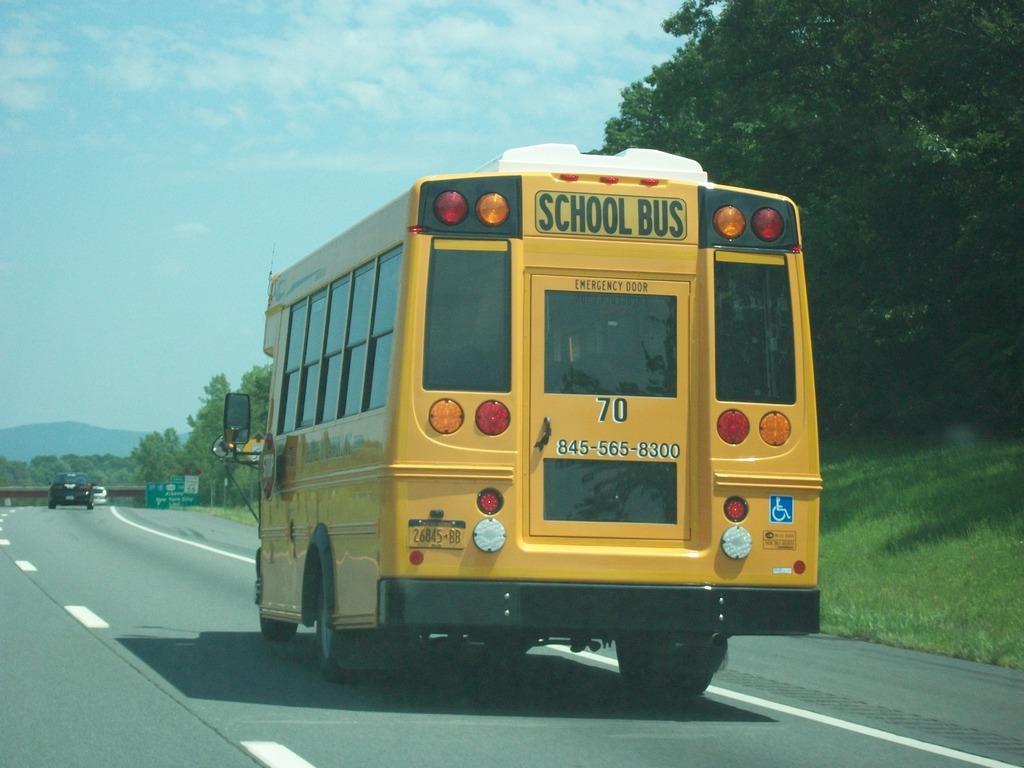Can you describe this image briefly? In this image we can see a yellow color school bus and other vehicles are moving on the road. Here we can see grass, trees, boards, bridge, hills and the sky in the background. 